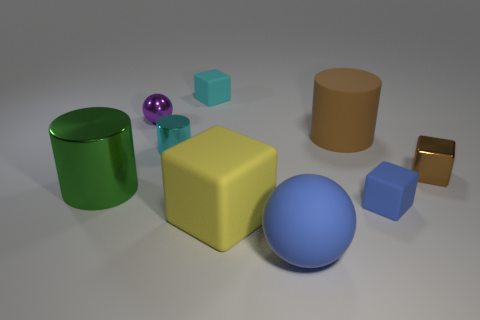How many objects are there, and can you describe their shapes? There is a total of seven objects in the image. From left to right, there is a green cylinder, a blue sphere, a yellow cube, a smaller cyan cube, a smaller metallic cyan cylinder, a brown cylinder, and a tiny, reflective gold cube. Which object appears to be the largest? The yellow cube seems to be the largest object given its proportion relative to the other items. 